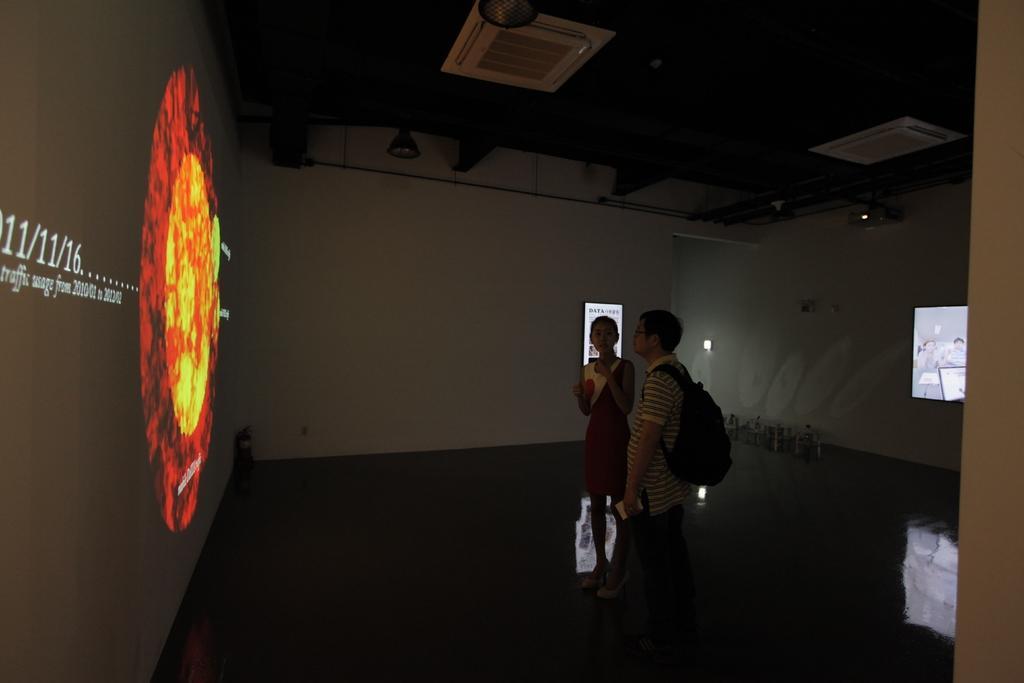Can you describe this image briefly? In this picture there is a man and a woman in the center of the image and there are screens around the wall, there are lamps on the roof at the top side of the image. 